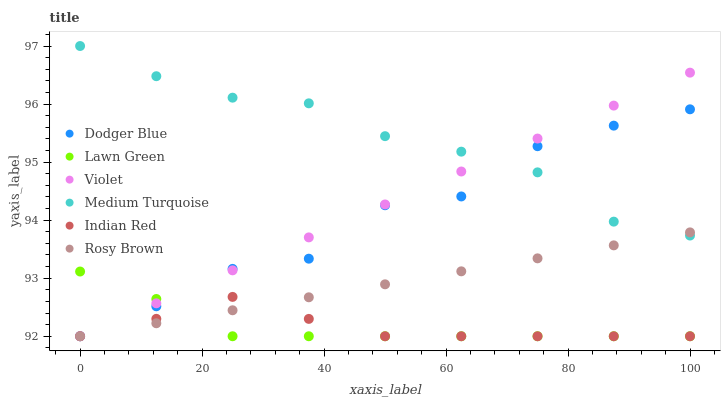Does Lawn Green have the minimum area under the curve?
Answer yes or no. Yes. Does Medium Turquoise have the maximum area under the curve?
Answer yes or no. Yes. Does Rosy Brown have the minimum area under the curve?
Answer yes or no. No. Does Rosy Brown have the maximum area under the curve?
Answer yes or no. No. Is Violet the smoothest?
Answer yes or no. Yes. Is Dodger Blue the roughest?
Answer yes or no. Yes. Is Medium Turquoise the smoothest?
Answer yes or no. No. Is Medium Turquoise the roughest?
Answer yes or no. No. Does Lawn Green have the lowest value?
Answer yes or no. Yes. Does Medium Turquoise have the lowest value?
Answer yes or no. No. Does Medium Turquoise have the highest value?
Answer yes or no. Yes. Does Rosy Brown have the highest value?
Answer yes or no. No. Is Lawn Green less than Medium Turquoise?
Answer yes or no. Yes. Is Medium Turquoise greater than Indian Red?
Answer yes or no. Yes. Does Rosy Brown intersect Lawn Green?
Answer yes or no. Yes. Is Rosy Brown less than Lawn Green?
Answer yes or no. No. Is Rosy Brown greater than Lawn Green?
Answer yes or no. No. Does Lawn Green intersect Medium Turquoise?
Answer yes or no. No. 